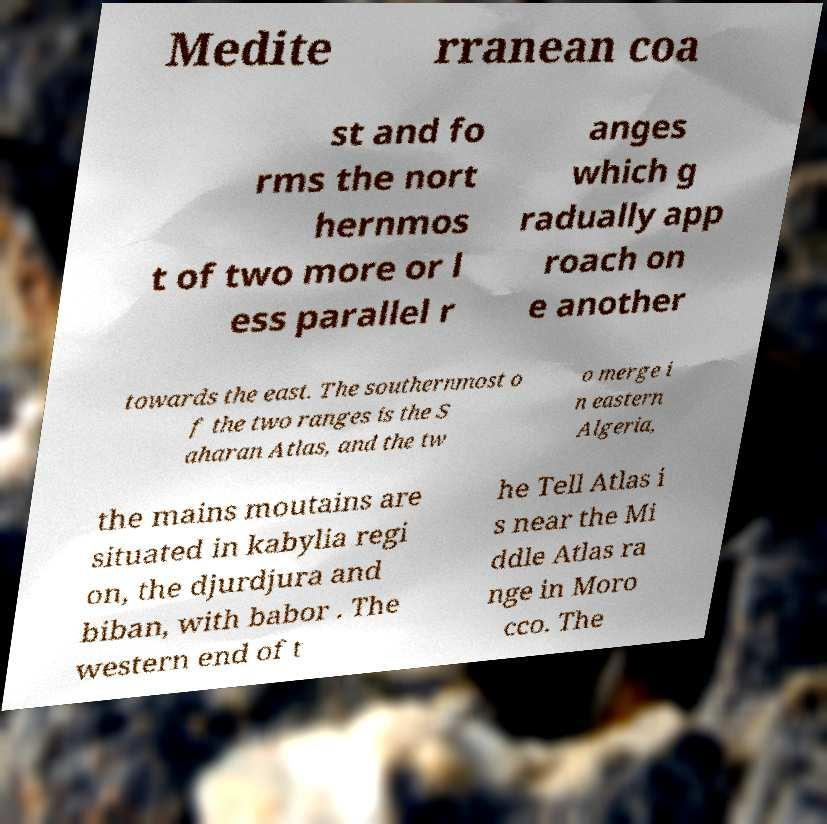What messages or text are displayed in this image? I need them in a readable, typed format. Medite rranean coa st and fo rms the nort hernmos t of two more or l ess parallel r anges which g radually app roach on e another towards the east. The southernmost o f the two ranges is the S aharan Atlas, and the tw o merge i n eastern Algeria, the mains moutains are situated in kabylia regi on, the djurdjura and biban, with babor . The western end of t he Tell Atlas i s near the Mi ddle Atlas ra nge in Moro cco. The 